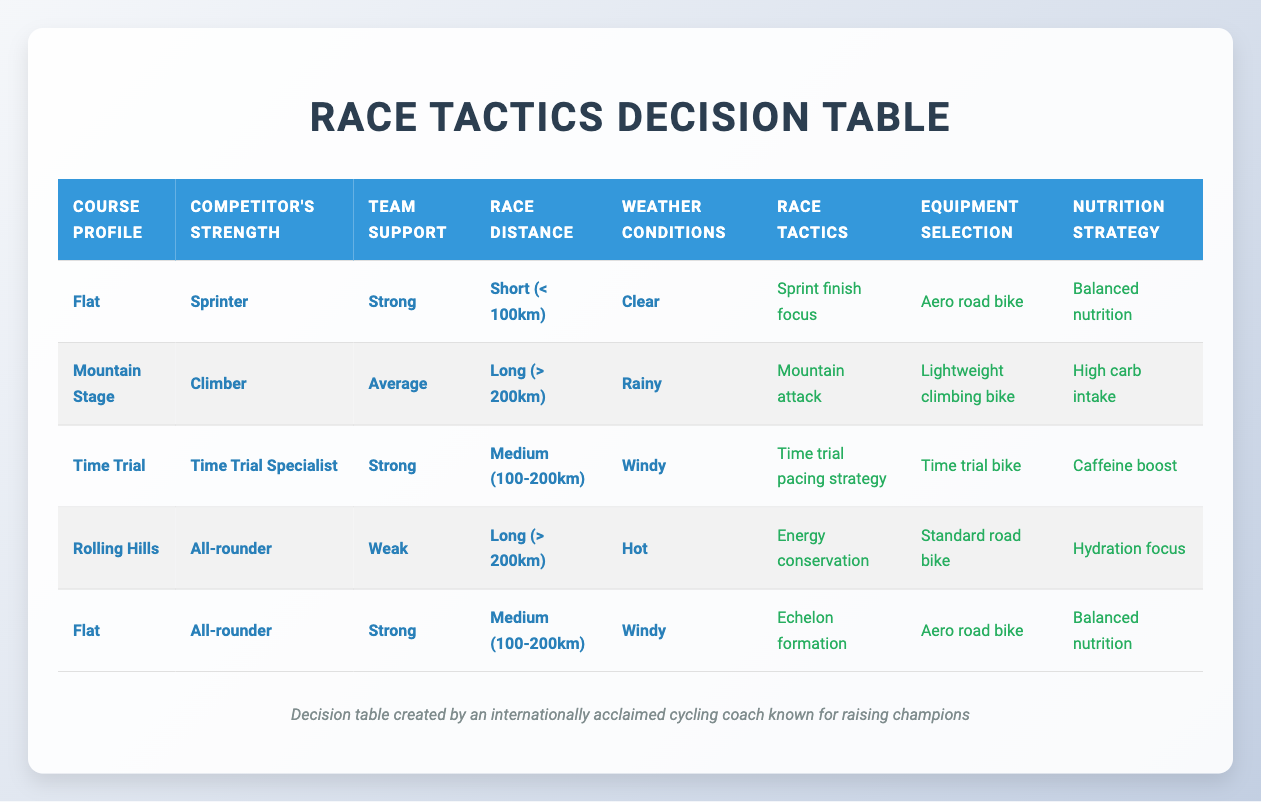What race tactic is recommended for a sprinter on a flat course with strong team support and clear weather? The table shows that when the Course Profile is "Flat," Competitor's Strength is "Sprinter," Team Support is "Strong," and Weather Conditions are "Clear," the recommended Race Tactics are "Sprint finish focus."
Answer: Sprint finish focus Is the equipment selection for a climber in a rainy mountain stage a lightweight climbing bike? In the entry for the "Mountain Stage" with "Climber" as the Competitor's Strength and "Rainy" as the Weather Condition, the Equipment Selection is indeed "Lightweight climbing bike." Therefore, the statement is true.
Answer: Yes For an all-rounder with weak team support in hot weather on a long course, what is the nutrition strategy? The table specifies that for an "All-rounder" with "Weak" team support in "Hot" conditions on a "Long" course, the Nutrition Strategy is "Hydration focus."
Answer: Hydration focus What equipment would you choose for an all-rounder on a flat course with strong team support and windy weather over a medium distance? The table indicates that for "Flat" courses with "All-rounder" strength, "Strong" team support, "Windy" weather, and "Medium (100-200km)" distance, the Equipment Selection should be an "Aero road bike."
Answer: Aero road bike If the race distance is long, what would be the race tactic for a climber in average team support during a rainy mountain stage? According to the data for a "Mountain Stage" with "Climber" as the Competitor's Strength, "Average" team support, "Long (> 200km)" distance, and "Rainy" conditions, the chosen Race Tactics is "Mountain attack."
Answer: Mountain attack Are there any strategies for time trial specialists competing on a windy time trial course of medium distance? The table indicates that for a "Time Trial" course with "Time Trial Specialist" strength, "Strong" team support, "Medium (100-200km)," and "Windy" weather, the actions suggested are a "Time trial pacing strategy." Hence, there is a strategy advising how to approach this situation.
Answer: Yes What two race tactics would you choose if faced with rolling hills, a weak team, an all-rounder, and hot weather on a long race? The table specifies that under these conditions, the Race Tactics should focus on "Energy conservation." There's only one specific tactic listed for those conditions, so only one can be chosen.
Answer: Energy conservation How should the nutrition strategy change if the weather conditions turn from clear to windy for a sprinter on a flat short course? Reviewing the conditions set for a "Flat" course with "Sprinter" strength and "Strong" team support on a "Short (< 100km)" distance, the Nutrition Strategy remains "Balanced nutrition" regardless of the weather being clear or windy. Therefore, it does not change in this case.
Answer: No change What is the total number of different race tactics suggested for the various configurations in the table? The table lists a total of 7 unique race tactics: "Aggressive breakaway," "Defensive riding," "Sprint finish focus," "Mountain attack," "Steady tempo riding," "Echelon formation," and "Time trial pacing strategy." Adding these values gives a total of 7 distinct tactics.
Answer: 7 